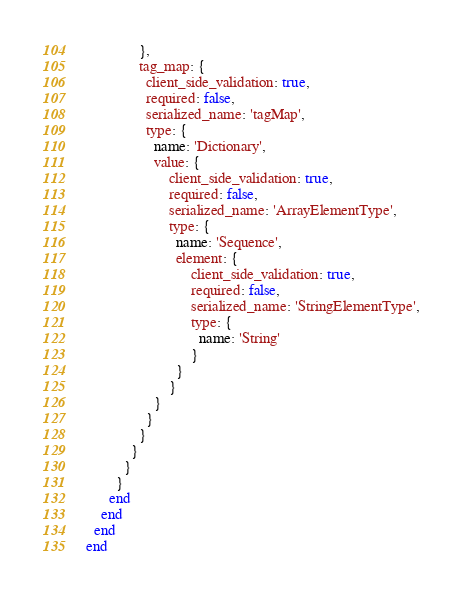<code> <loc_0><loc_0><loc_500><loc_500><_Ruby_>              },
              tag_map: {
                client_side_validation: true,
                required: false,
                serialized_name: 'tagMap',
                type: {
                  name: 'Dictionary',
                  value: {
                      client_side_validation: true,
                      required: false,
                      serialized_name: 'ArrayElementType',
                      type: {
                        name: 'Sequence',
                        element: {
                            client_side_validation: true,
                            required: false,
                            serialized_name: 'StringElementType',
                            type: {
                              name: 'String'
                            }
                        }
                      }
                  }
                }
              }
            }
          }
        }
      end
    end
  end
end
</code> 